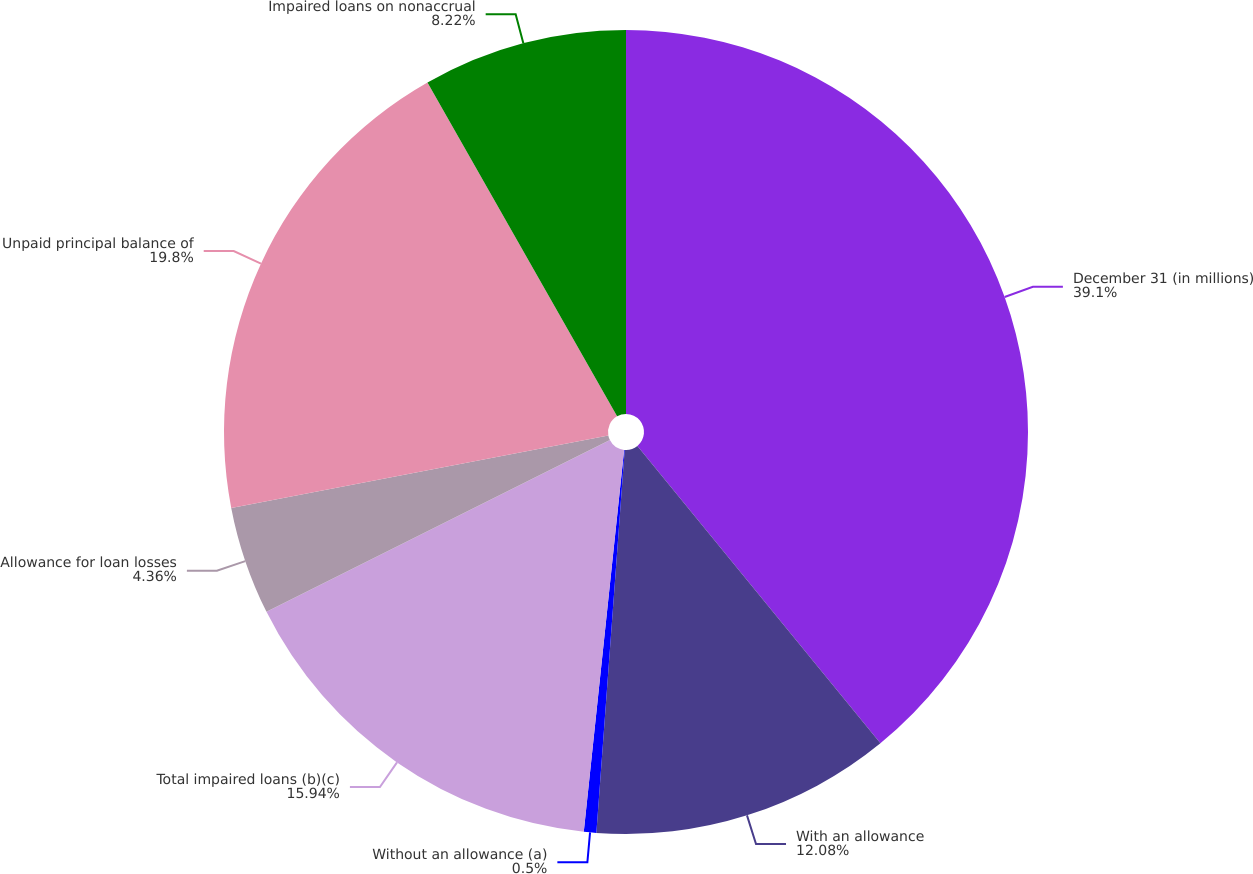Convert chart. <chart><loc_0><loc_0><loc_500><loc_500><pie_chart><fcel>December 31 (in millions)<fcel>With an allowance<fcel>Without an allowance (a)<fcel>Total impaired loans (b)(c)<fcel>Allowance for loan losses<fcel>Unpaid principal balance of<fcel>Impaired loans on nonaccrual<nl><fcel>39.09%<fcel>12.08%<fcel>0.5%<fcel>15.94%<fcel>4.36%<fcel>19.8%<fcel>8.22%<nl></chart> 